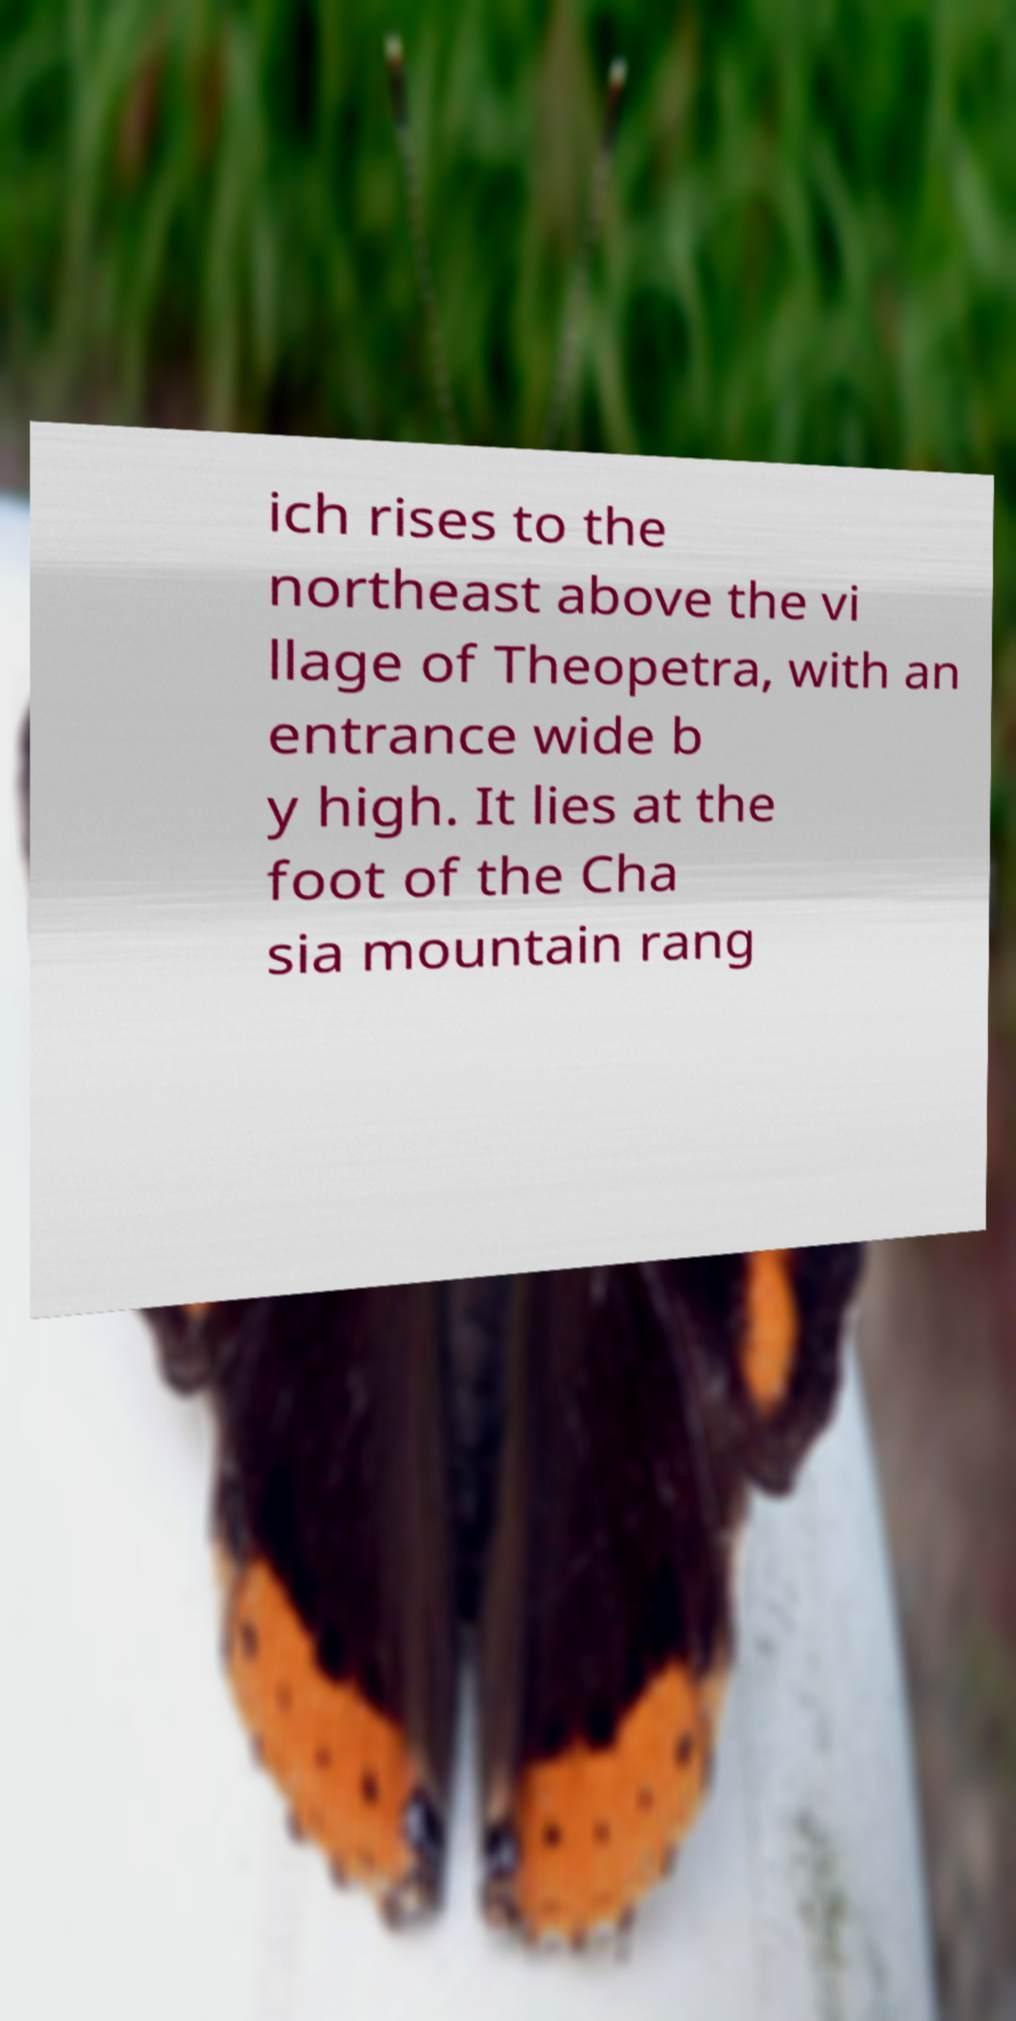Could you assist in decoding the text presented in this image and type it out clearly? ich rises to the northeast above the vi llage of Theopetra, with an entrance wide b y high. It lies at the foot of the Cha sia mountain rang 